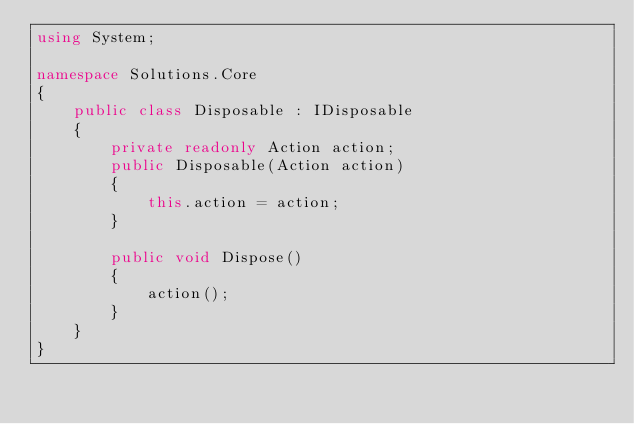Convert code to text. <code><loc_0><loc_0><loc_500><loc_500><_C#_>using System;

namespace Solutions.Core
{
    public class Disposable : IDisposable
    {
        private readonly Action action;
        public Disposable(Action action)
        {
            this.action = action;
        }

        public void Dispose()
        {
            action();
        }
    }
}</code> 